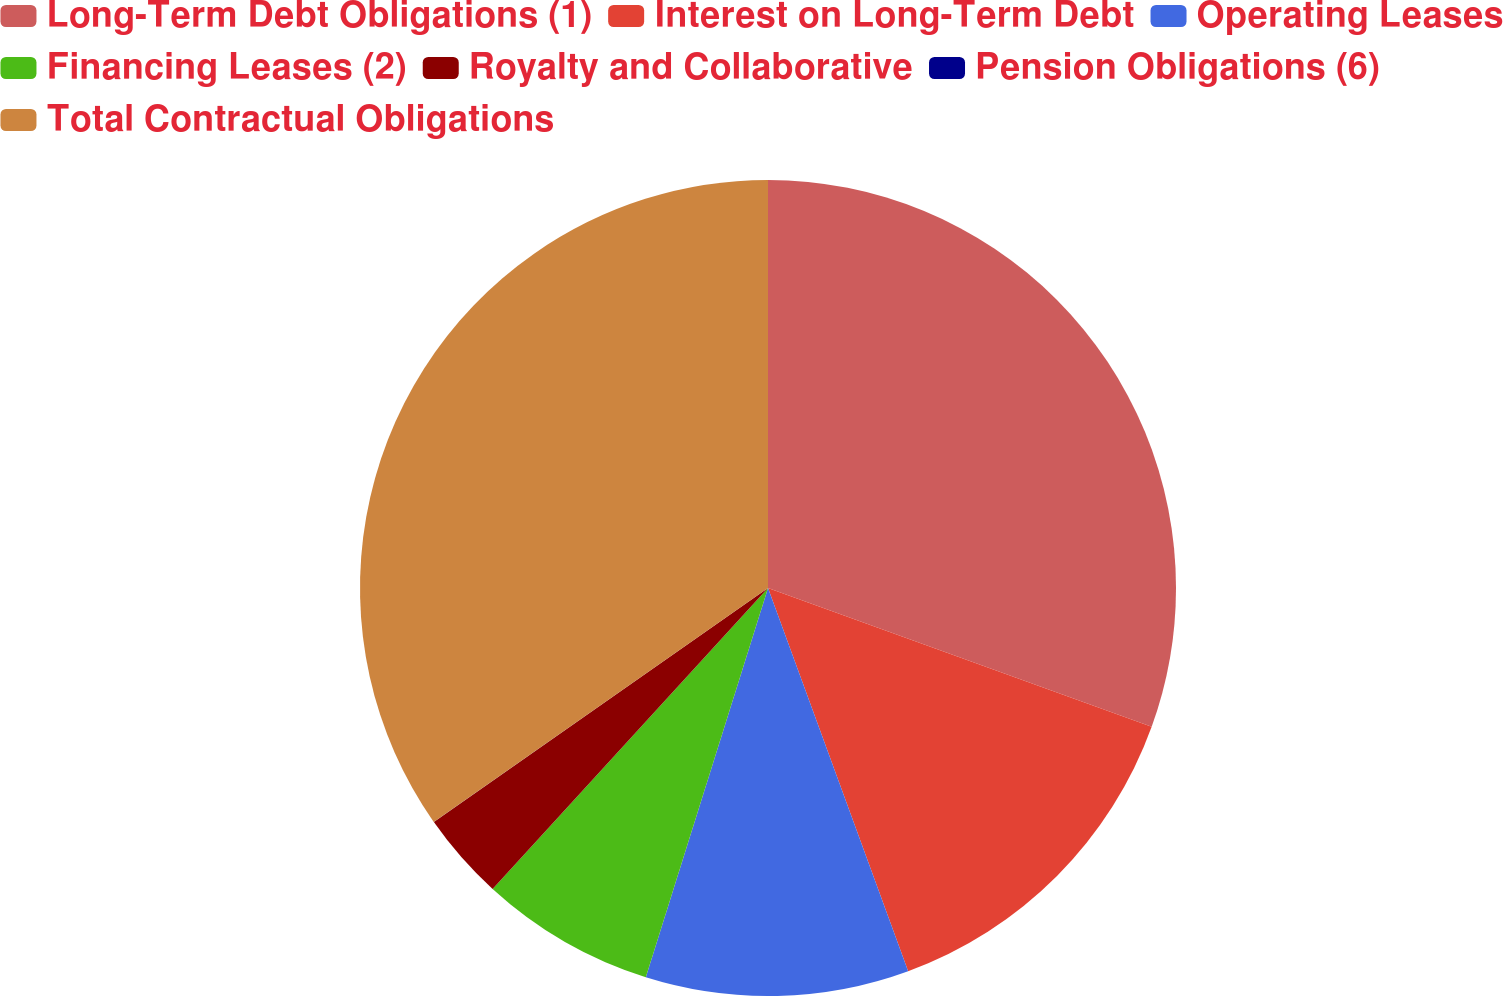Convert chart to OTSL. <chart><loc_0><loc_0><loc_500><loc_500><pie_chart><fcel>Long-Term Debt Obligations (1)<fcel>Interest on Long-Term Debt<fcel>Operating Leases<fcel>Financing Leases (2)<fcel>Royalty and Collaborative<fcel>Pension Obligations (6)<fcel>Total Contractual Obligations<nl><fcel>30.52%<fcel>13.89%<fcel>10.42%<fcel>6.95%<fcel>3.48%<fcel>0.01%<fcel>34.71%<nl></chart> 